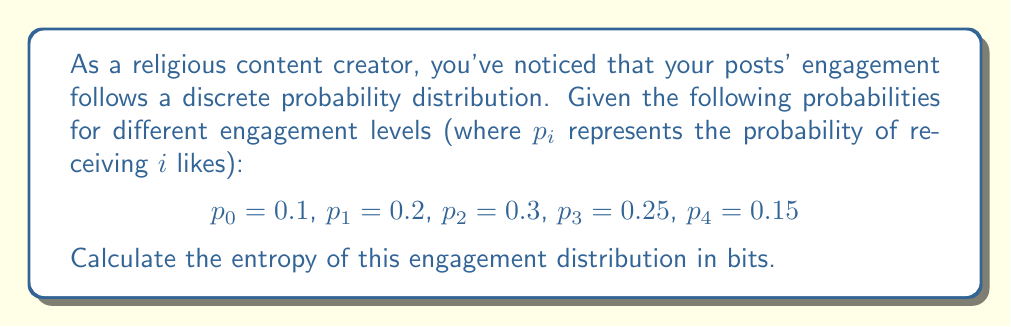Show me your answer to this math problem. To calculate the entropy of the engagement distribution, we'll use the formula for Shannon entropy:

$$S = -\sum_{i} p_i \log_2(p_i)$$

where $p_i$ is the probability of each outcome and the logarithm is base 2 for entropy in bits.

Let's calculate each term:

1) For $p_0 = 0.1$:
   $-0.1 \log_2(0.1) = 0.332$

2) For $p_1 = 0.2$:
   $-0.2 \log_2(0.2) = 0.464$

3) For $p_2 = 0.3$:
   $-0.3 \log_2(0.3) = 0.521$

4) For $p_3 = 0.25$:
   $-0.25 \log_2(0.25) = 0.5$

5) For $p_4 = 0.15$:
   $-0.15 \log_2(0.15) = 0.411$

Now, sum all these terms:

$S = 0.332 + 0.464 + 0.521 + 0.5 + 0.411 = 2.228$

Therefore, the entropy of the engagement distribution is approximately 2.228 bits.
Answer: 2.228 bits 